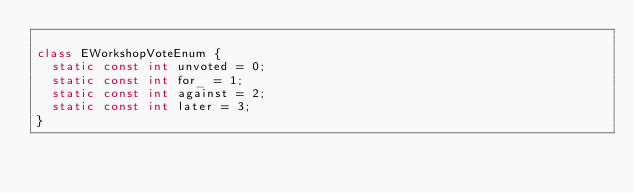Convert code to text. <code><loc_0><loc_0><loc_500><loc_500><_Dart_>
class EWorkshopVoteEnum {
  static const int unvoted = 0;
  static const int for_ = 1;
  static const int against = 2;
  static const int later = 3;
}
</code> 